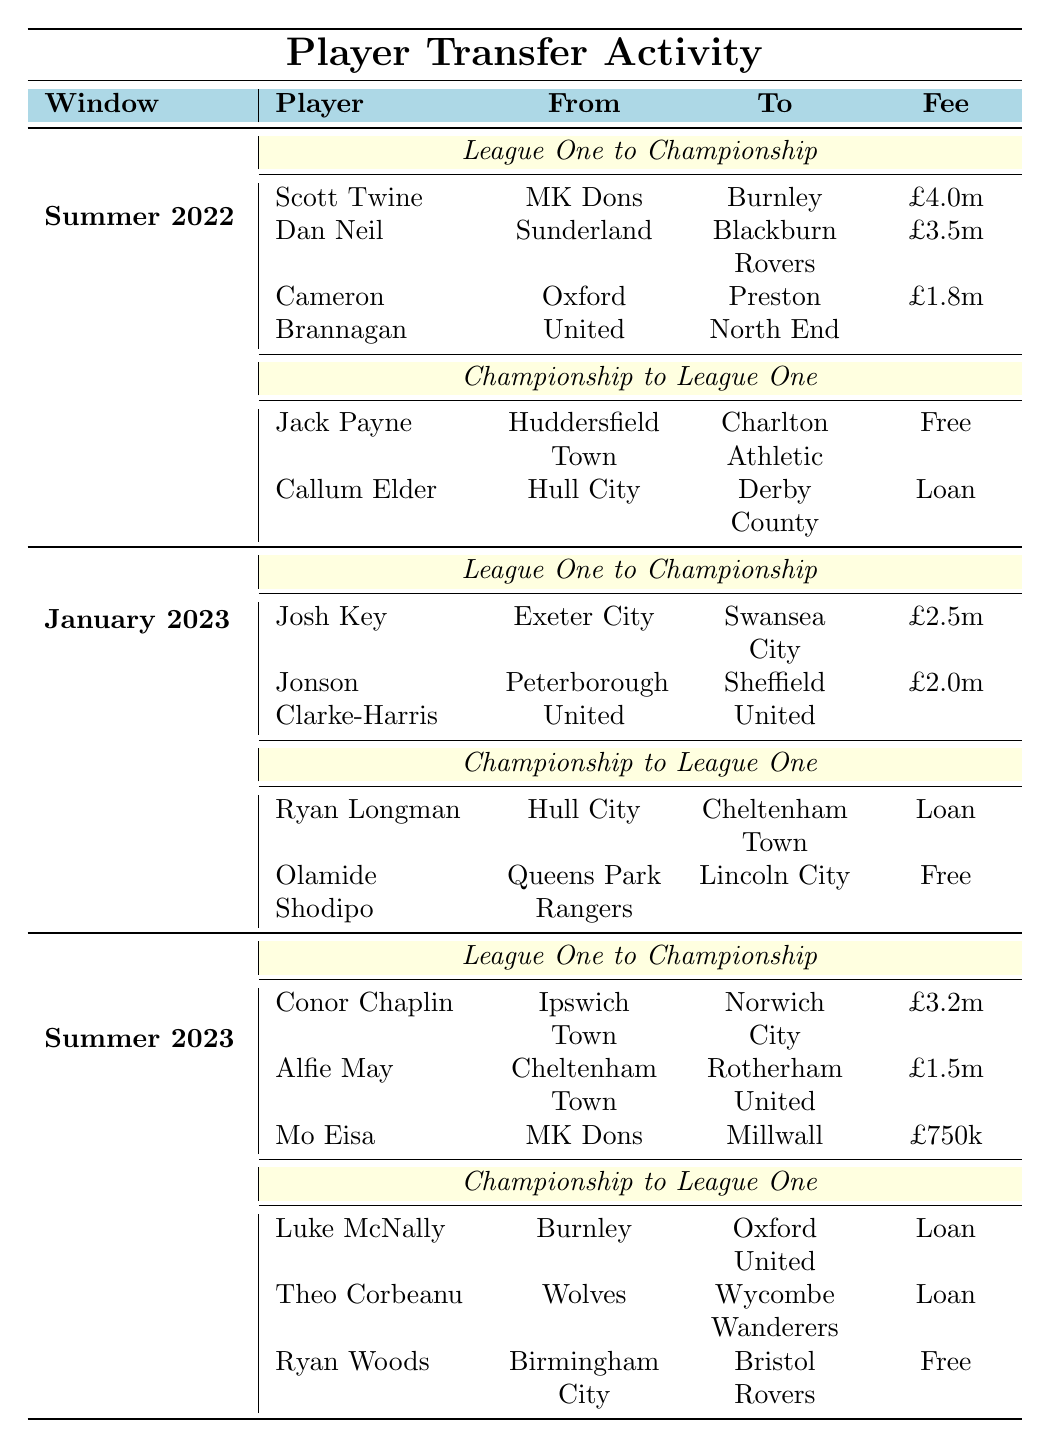What players transferred from League One to the Championship in Summer 2022? In the Summer 2022 transfer window, the players who transferred from League One to the Championship are Scott Twine (from MK Dons to Burnley), Dan Neil (from Sunderland to Blackburn Rovers), and Cameron Brannagan (from Oxford United to Preston North End).
Answer: Scott Twine, Dan Neil, Cameron Brannagan What was the total fee paid for transfers from League One to Championship in Summer 2023? In Summer 2023, the fees for players transferring from League One to Championship are: Conor Chaplin (£3.2m), Alfie May (£1.5m), and Mo Eisa (£750k). The sum of these fees is £3.2m + £1.5m + £0.75m = £5.45m.
Answer: £5.45m Did any players transfer from Championship to League One during the January 2023 window? Yes, two players transferred from Championship to League One in January 2023: Ryan Longman (from Hull City to Cheltenham Town) and Olamide Shodipo (from Queens Park Rangers to Lincoln City).
Answer: Yes How many players transferred from Championship to League One in the last three windows combined? In the three transfer windows, there was 1 player in Summer 2022, 2 players in January 2023, and 3 players in Summer 2023 who transferred from Championship to League One. Adding them gives a total of 1 + 2 + 3 = 6 players.
Answer: 6 players Which player had the highest transfer fee from League One to the Championship in Summer 2022? The player with the highest transfer fee from League One to the Championship in Summer 2022 is Scott Twine, who transferred for £4.0m from MK Dons to Burnley.
Answer: Scott Twine What percentage of League One to Championship transfers were loans across all transfer windows? In total, there are 5 transfers from League One to Championship and 2 of these were loans (Callum Elder in Summer 2022 and Ryan Woods in Summer 2023). To find the percentage: (2 loans / 5 transfers) * 100 = 40%.
Answer: 40% Which Championship team received players from League One in Summer 2023, and how many transfers did they make? In Summer 2023, Rotherham United received one player (Alfie May) from League One, while Norwich City received one player (Conor Chaplin). Therefore, both teams combined had 2 transfers from League One.
Answer: 2 transfers (Rotherham United and Norwich City) What was the sum of the transfer fees for players who moved from Championship to League One in Summer 2023? In Summer 2023, three players transferred from Championship to League One: Luke McNally (Loan), Theo Corbeanu (Loan), and Ryan Woods (Free). Since loans and free transfers do not have specified fees, the sum of the fees for players receiving a fee is £0.
Answer: £0 